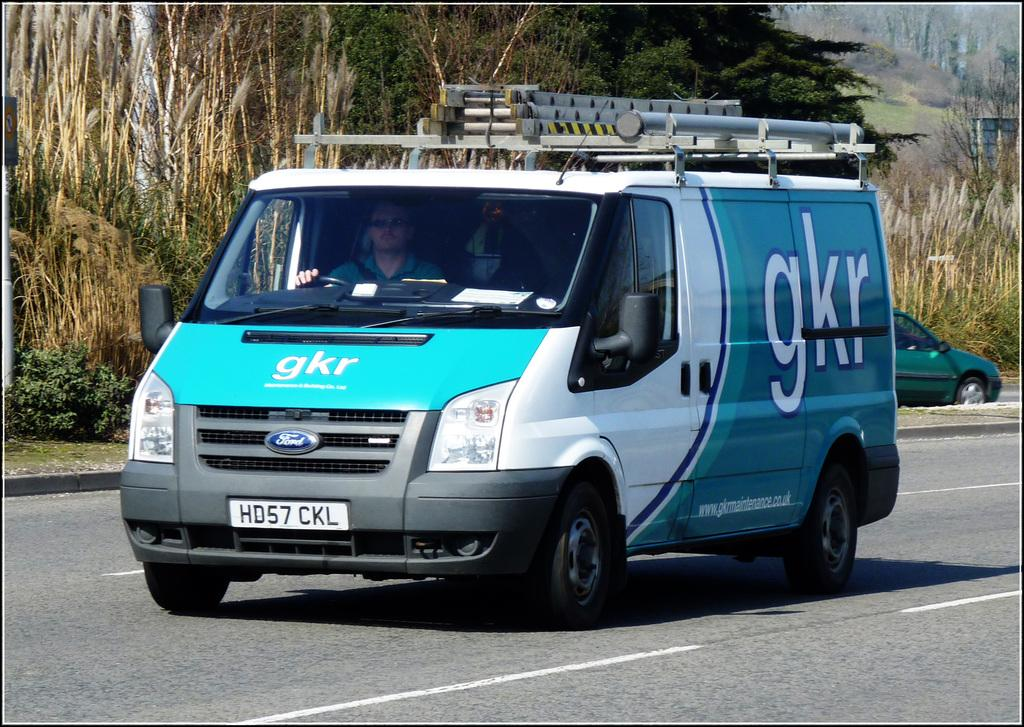<image>
Summarize the visual content of the image. gkr van man is driving along the street 